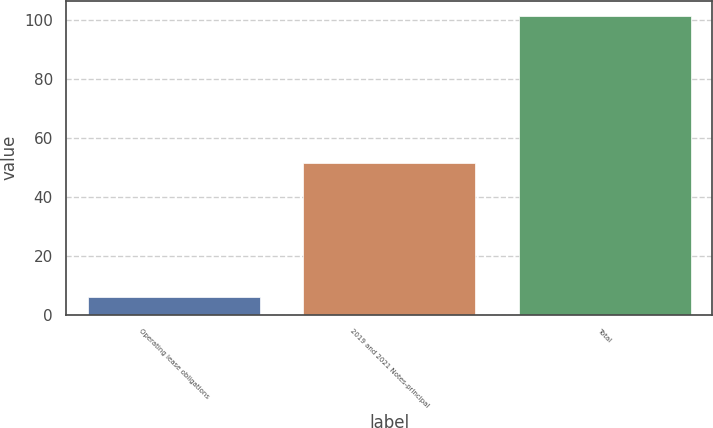<chart> <loc_0><loc_0><loc_500><loc_500><bar_chart><fcel>Operating lease obligations<fcel>2019 and 2021 Notes-principal<fcel>Total<nl><fcel>6.1<fcel>51.3<fcel>101.4<nl></chart> 